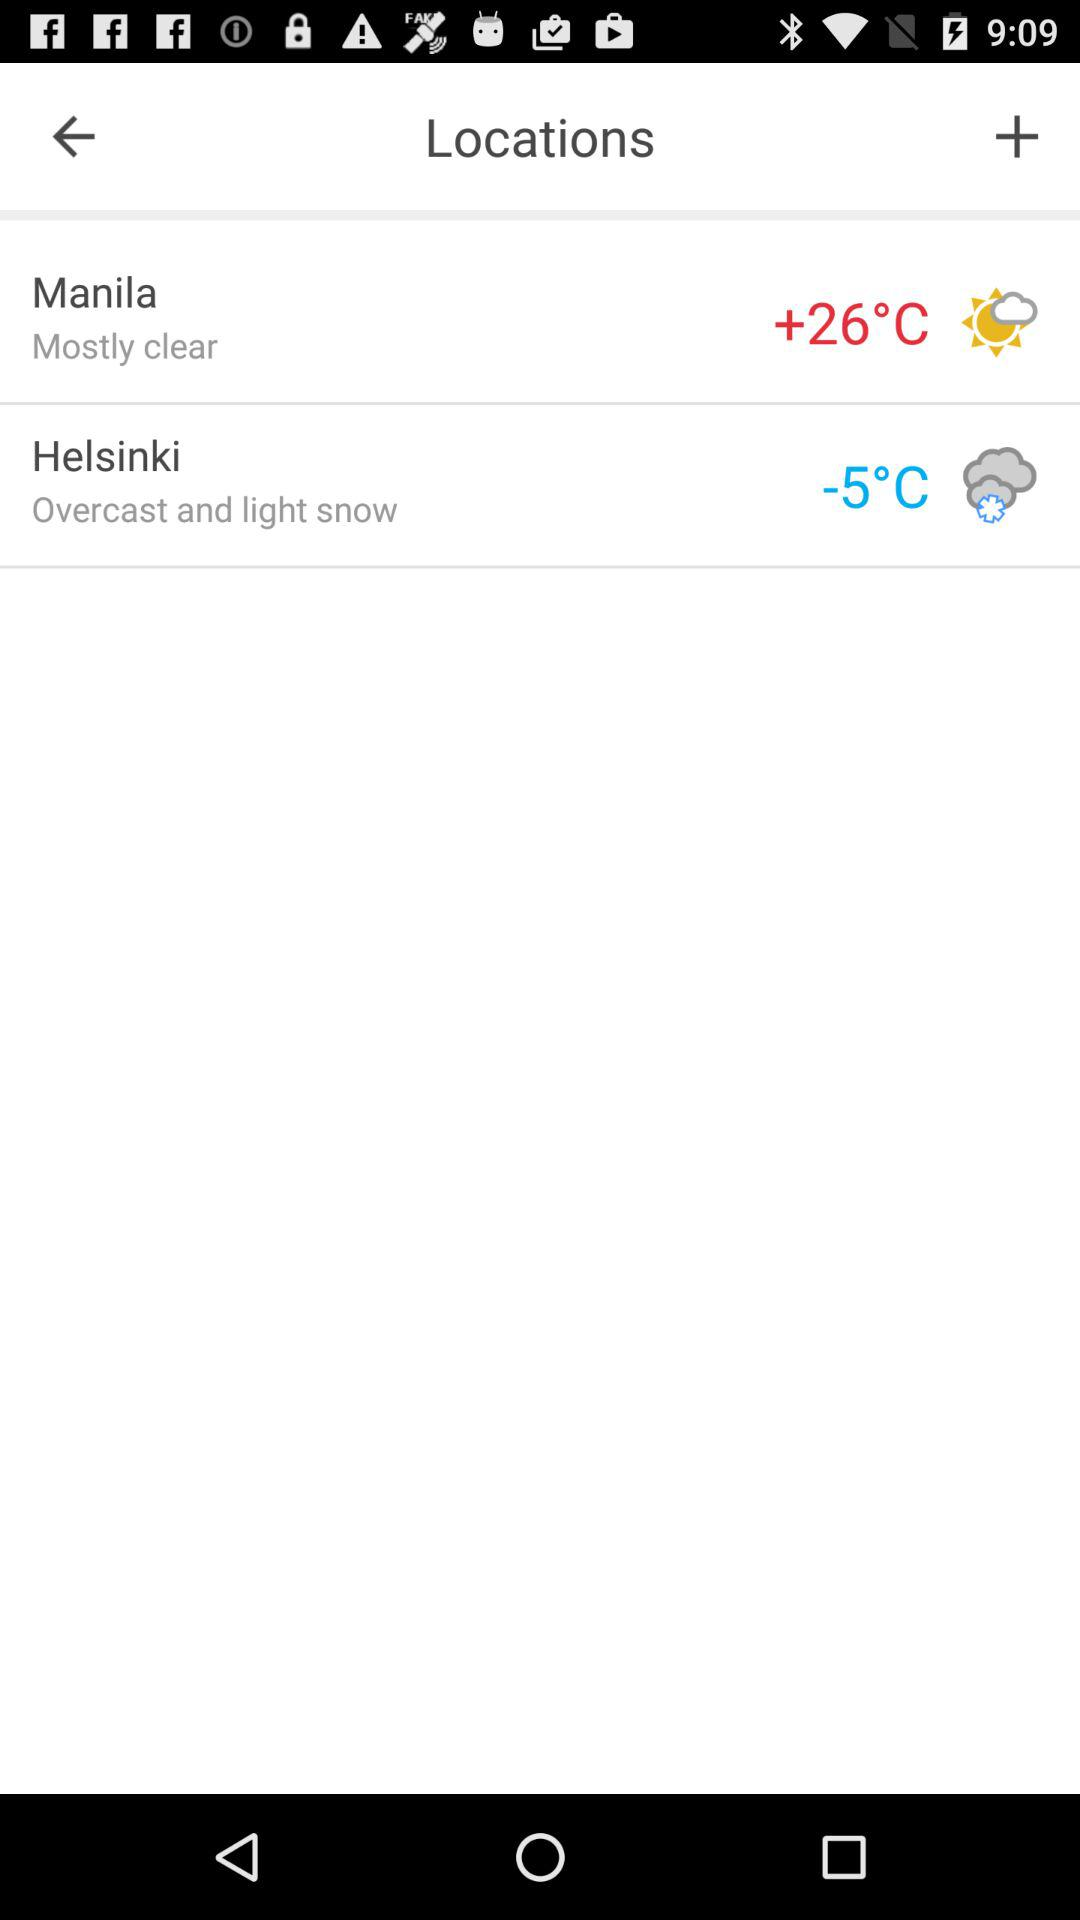How many degrees warmer is Manila than Helsinki?
Answer the question using a single word or phrase. 31 